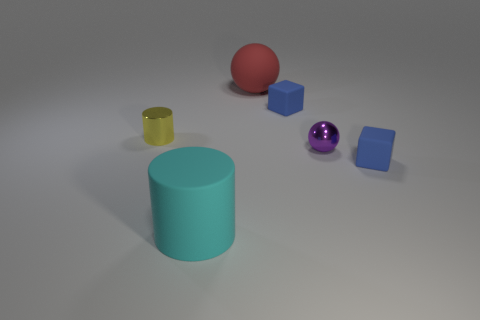What is the shape of the cyan object that is the same size as the red ball? The cyan object, which is of the same size as the red ball, is a cylinder. It exhibits a circular base and possesses a uniform shape throughout its height, which is a characteristic feature of a cylindrical object. 